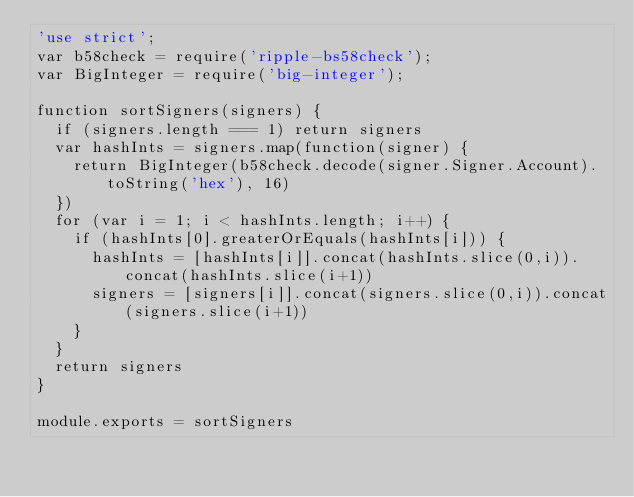<code> <loc_0><loc_0><loc_500><loc_500><_JavaScript_>'use strict';
var b58check = require('ripple-bs58check');
var BigInteger = require('big-integer');

function sortSigners(signers) {
  if (signers.length === 1) return signers
  var hashInts = signers.map(function(signer) {
    return BigInteger(b58check.decode(signer.Signer.Account).toString('hex'), 16)
  })
  for (var i = 1; i < hashInts.length; i++) {
    if (hashInts[0].greaterOrEquals(hashInts[i])) {
      hashInts = [hashInts[i]].concat(hashInts.slice(0,i)).concat(hashInts.slice(i+1))
      signers = [signers[i]].concat(signers.slice(0,i)).concat(signers.slice(i+1))
    }
  }
  return signers
}

module.exports = sortSigners
</code> 